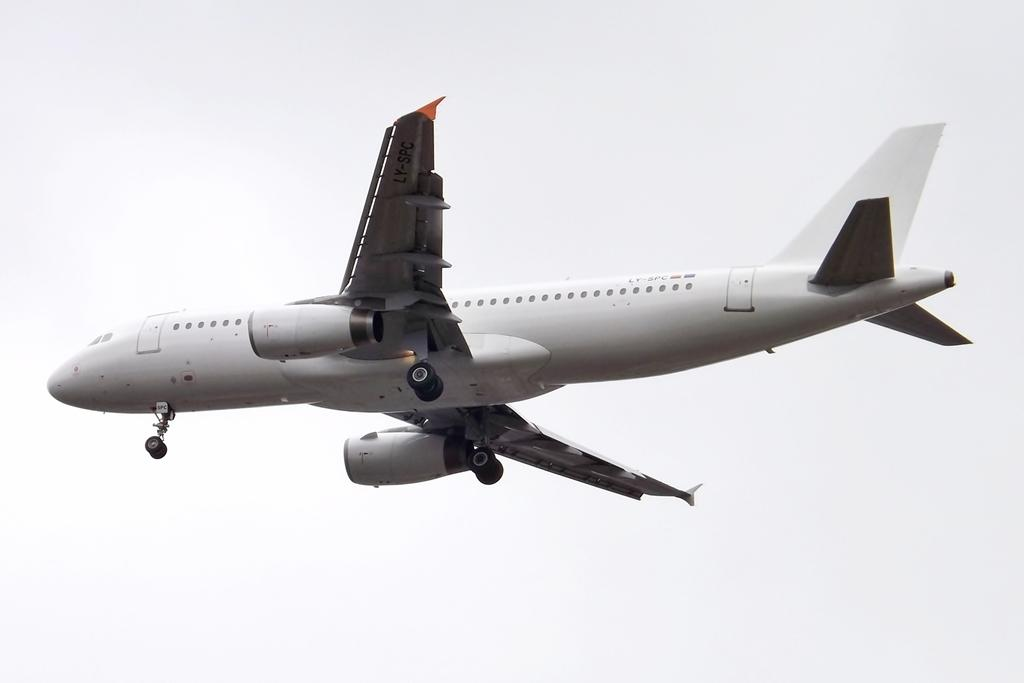What is the main subject of the image? The main subject of the image is an airplane. Can you describe the position of the airplane in the image? The airplane is in the air in the image. What color is the background of the image? The background of the image is white. What type of meal is being served in the airplane? There is no meal visible in the image, as it only features an airplane in the air with a white background. 